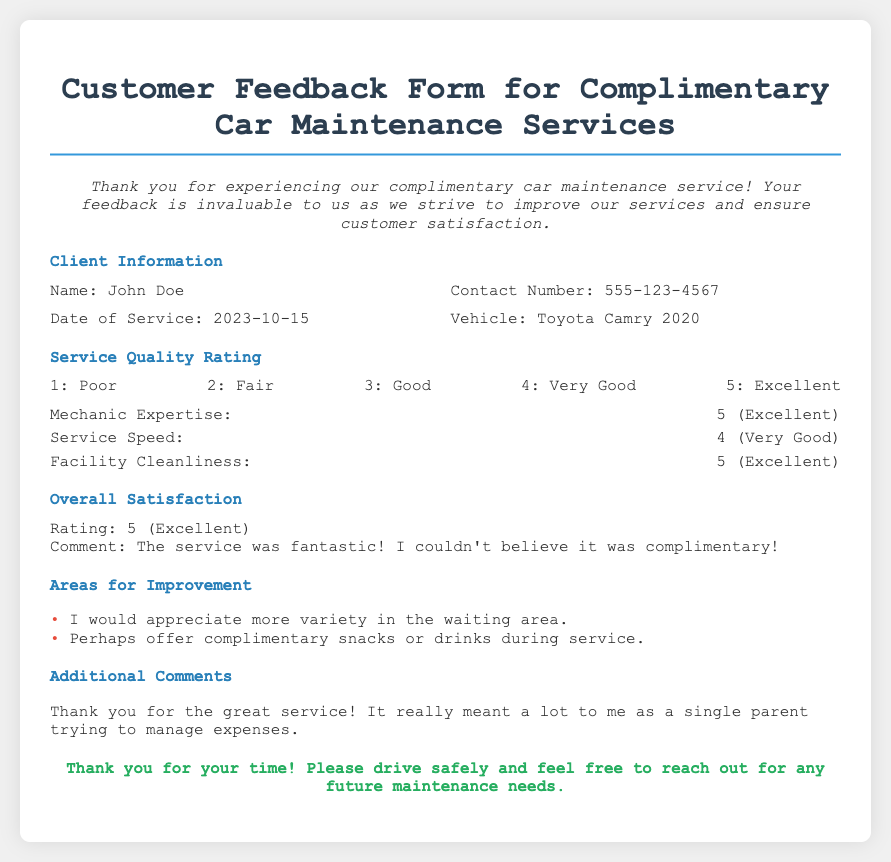What is the name of the client? The document lists the client's name in the Client Information section.
Answer: John Doe What is the contact number of the client? The contact number is provided in the Client Information section of the document.
Answer: 555-123-4567 On what date did the service occur? The date of service is included in the Client Information section.
Answer: 2023-10-15 What was the service quality rating for Mechanic Expertise? The rating for Mechanic Expertise is stated in the Service Quality Rating section of the document.
Answer: 5 (Excellent) What was the client's overall satisfaction rating? The overall satisfaction rating is provided in the Overall Satisfaction section.
Answer: 5 (Excellent) What area of improvement did the client suggest regarding the waiting area? The client mentioned the need for improvements in the waiting area under Areas for Improvement section.
Answer: More variety in the waiting area What additional service did the client suggest? The client provided suggestions in the Areas for Improvement section.
Answer: Offer complimentary snacks or drinks during service What comment did the client leave in the Additional Comments section? The Additional Comments section includes the client's remarks about the service.
Answer: Thank you for the great service! What type of vehicle did the client have? The document specifies the type of vehicle in the Client Information section.
Answer: Toyota Camry 2020 